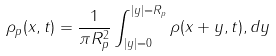Convert formula to latex. <formula><loc_0><loc_0><loc_500><loc_500>\rho _ { p } ( { x } , t ) = \frac { 1 } { \pi R _ { p } ^ { 2 } } \int _ { | { y } | = 0 } ^ { | { y } | = R _ { p } } \rho ( { x } + { y } , t ) , d { y }</formula> 